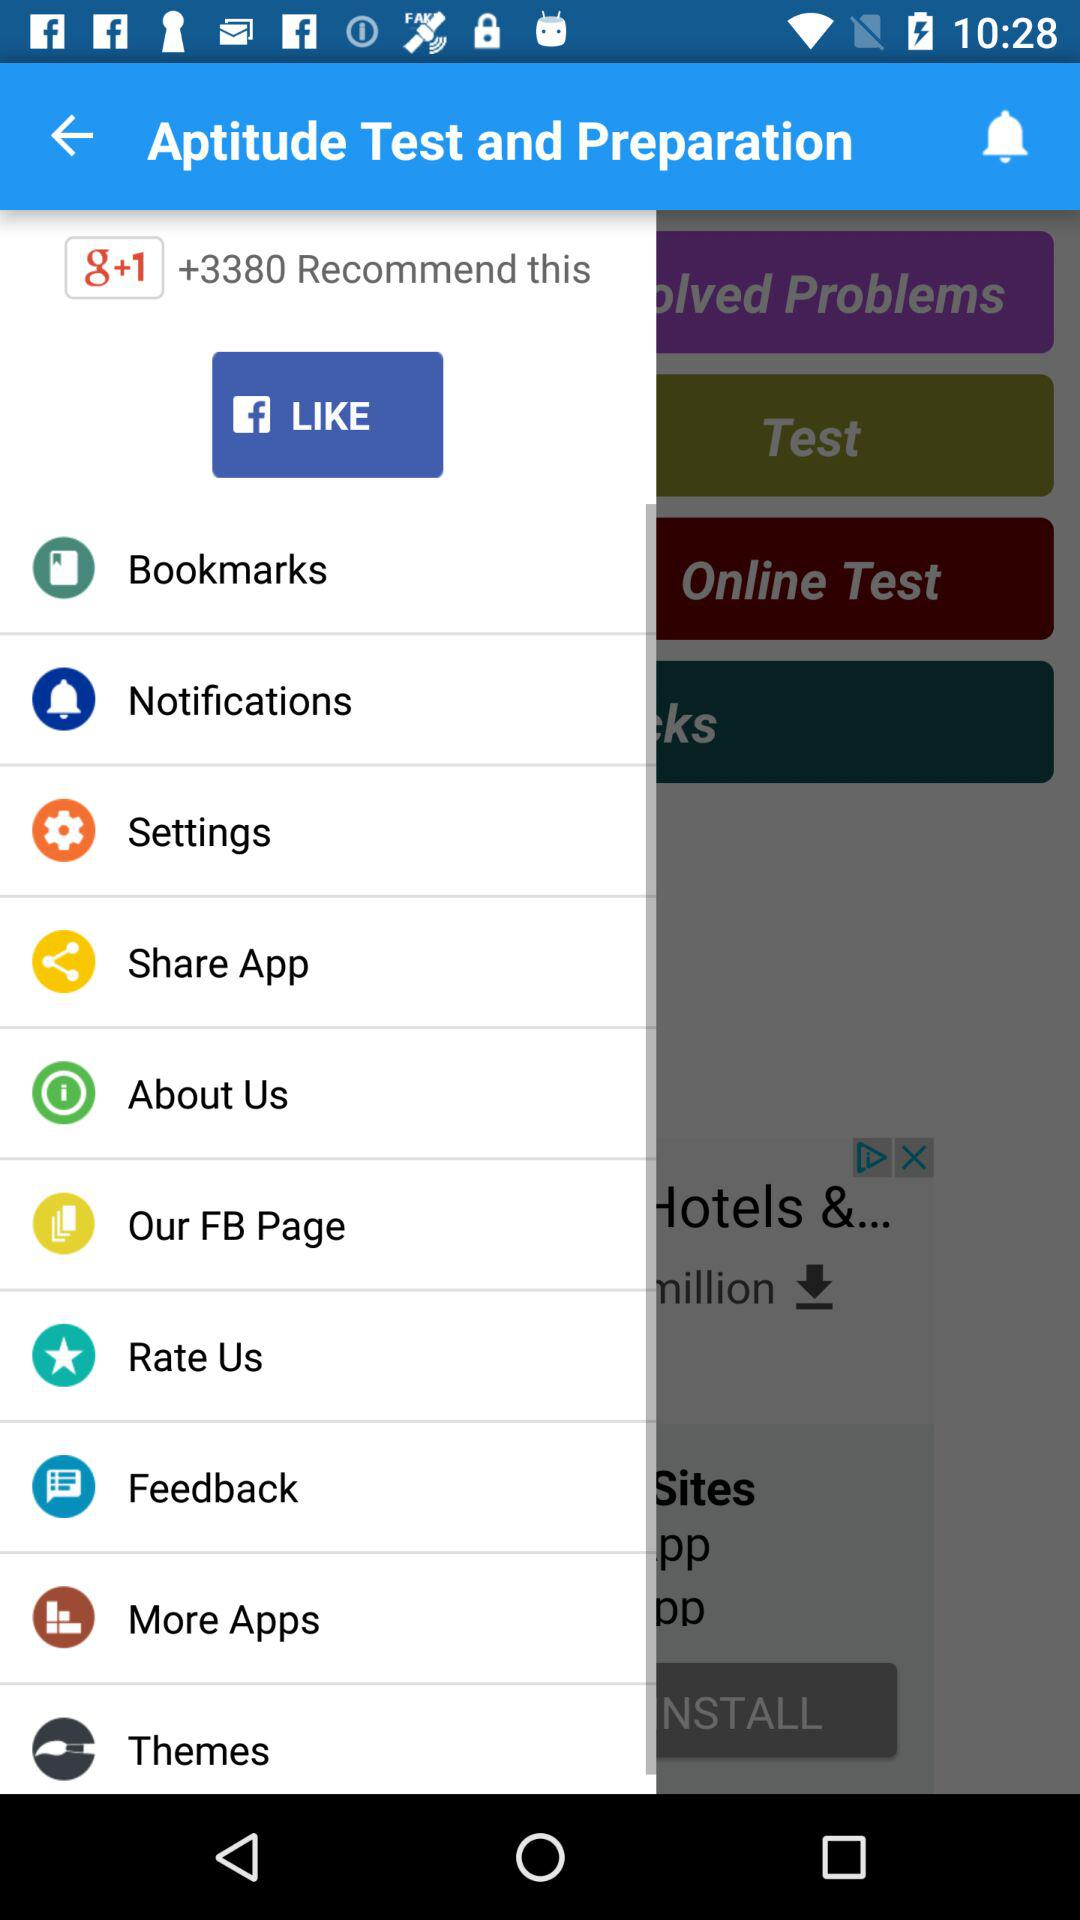What is the application name? The application name is "Aptitude Test and Preparation". 